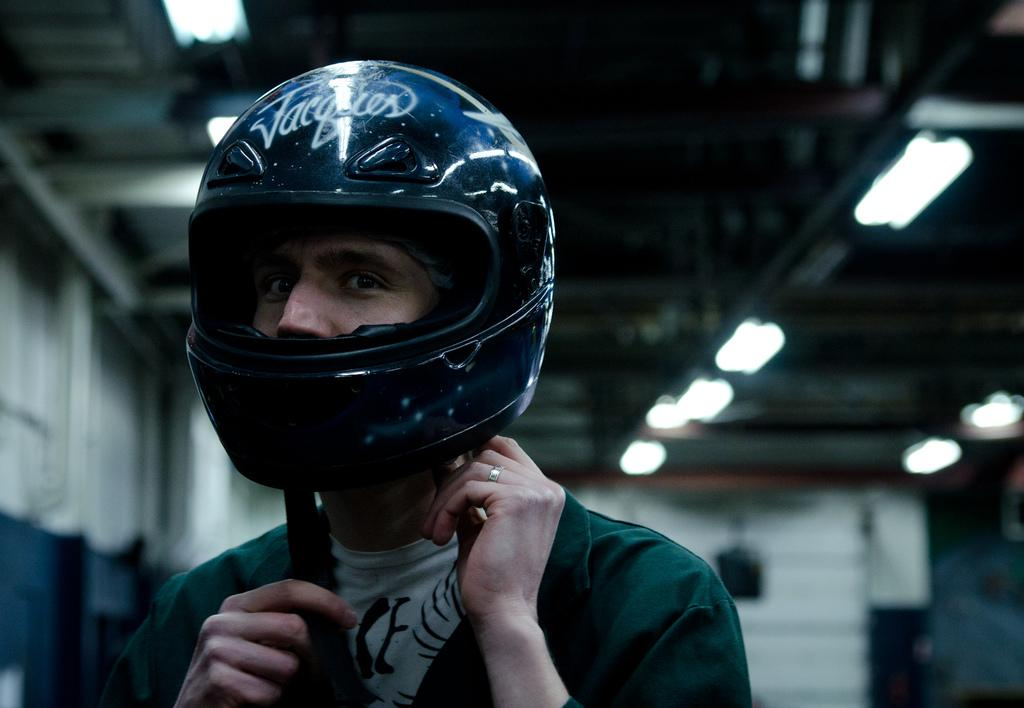Who is present in the image? There is a man in the image. What is the man wearing on his head? The man is wearing a helmet. What can be seen in the background of the image? There are walls, iron bars, and electric lights in the background of the image. Is the man's grandmother present in the image? There is no mention of a grandmother or any other person besides the man in the image. 